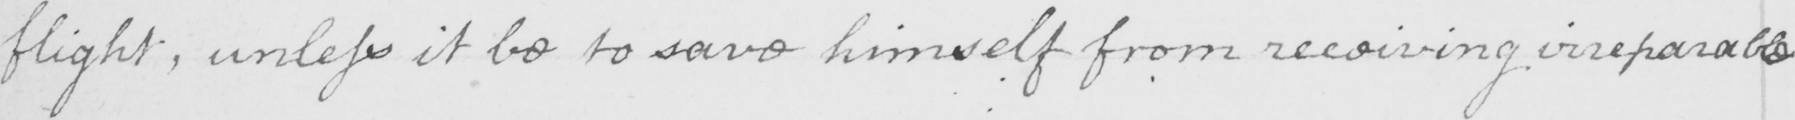Can you tell me what this handwritten text says? flight ; unless it be to save himself from receiving irreparable 